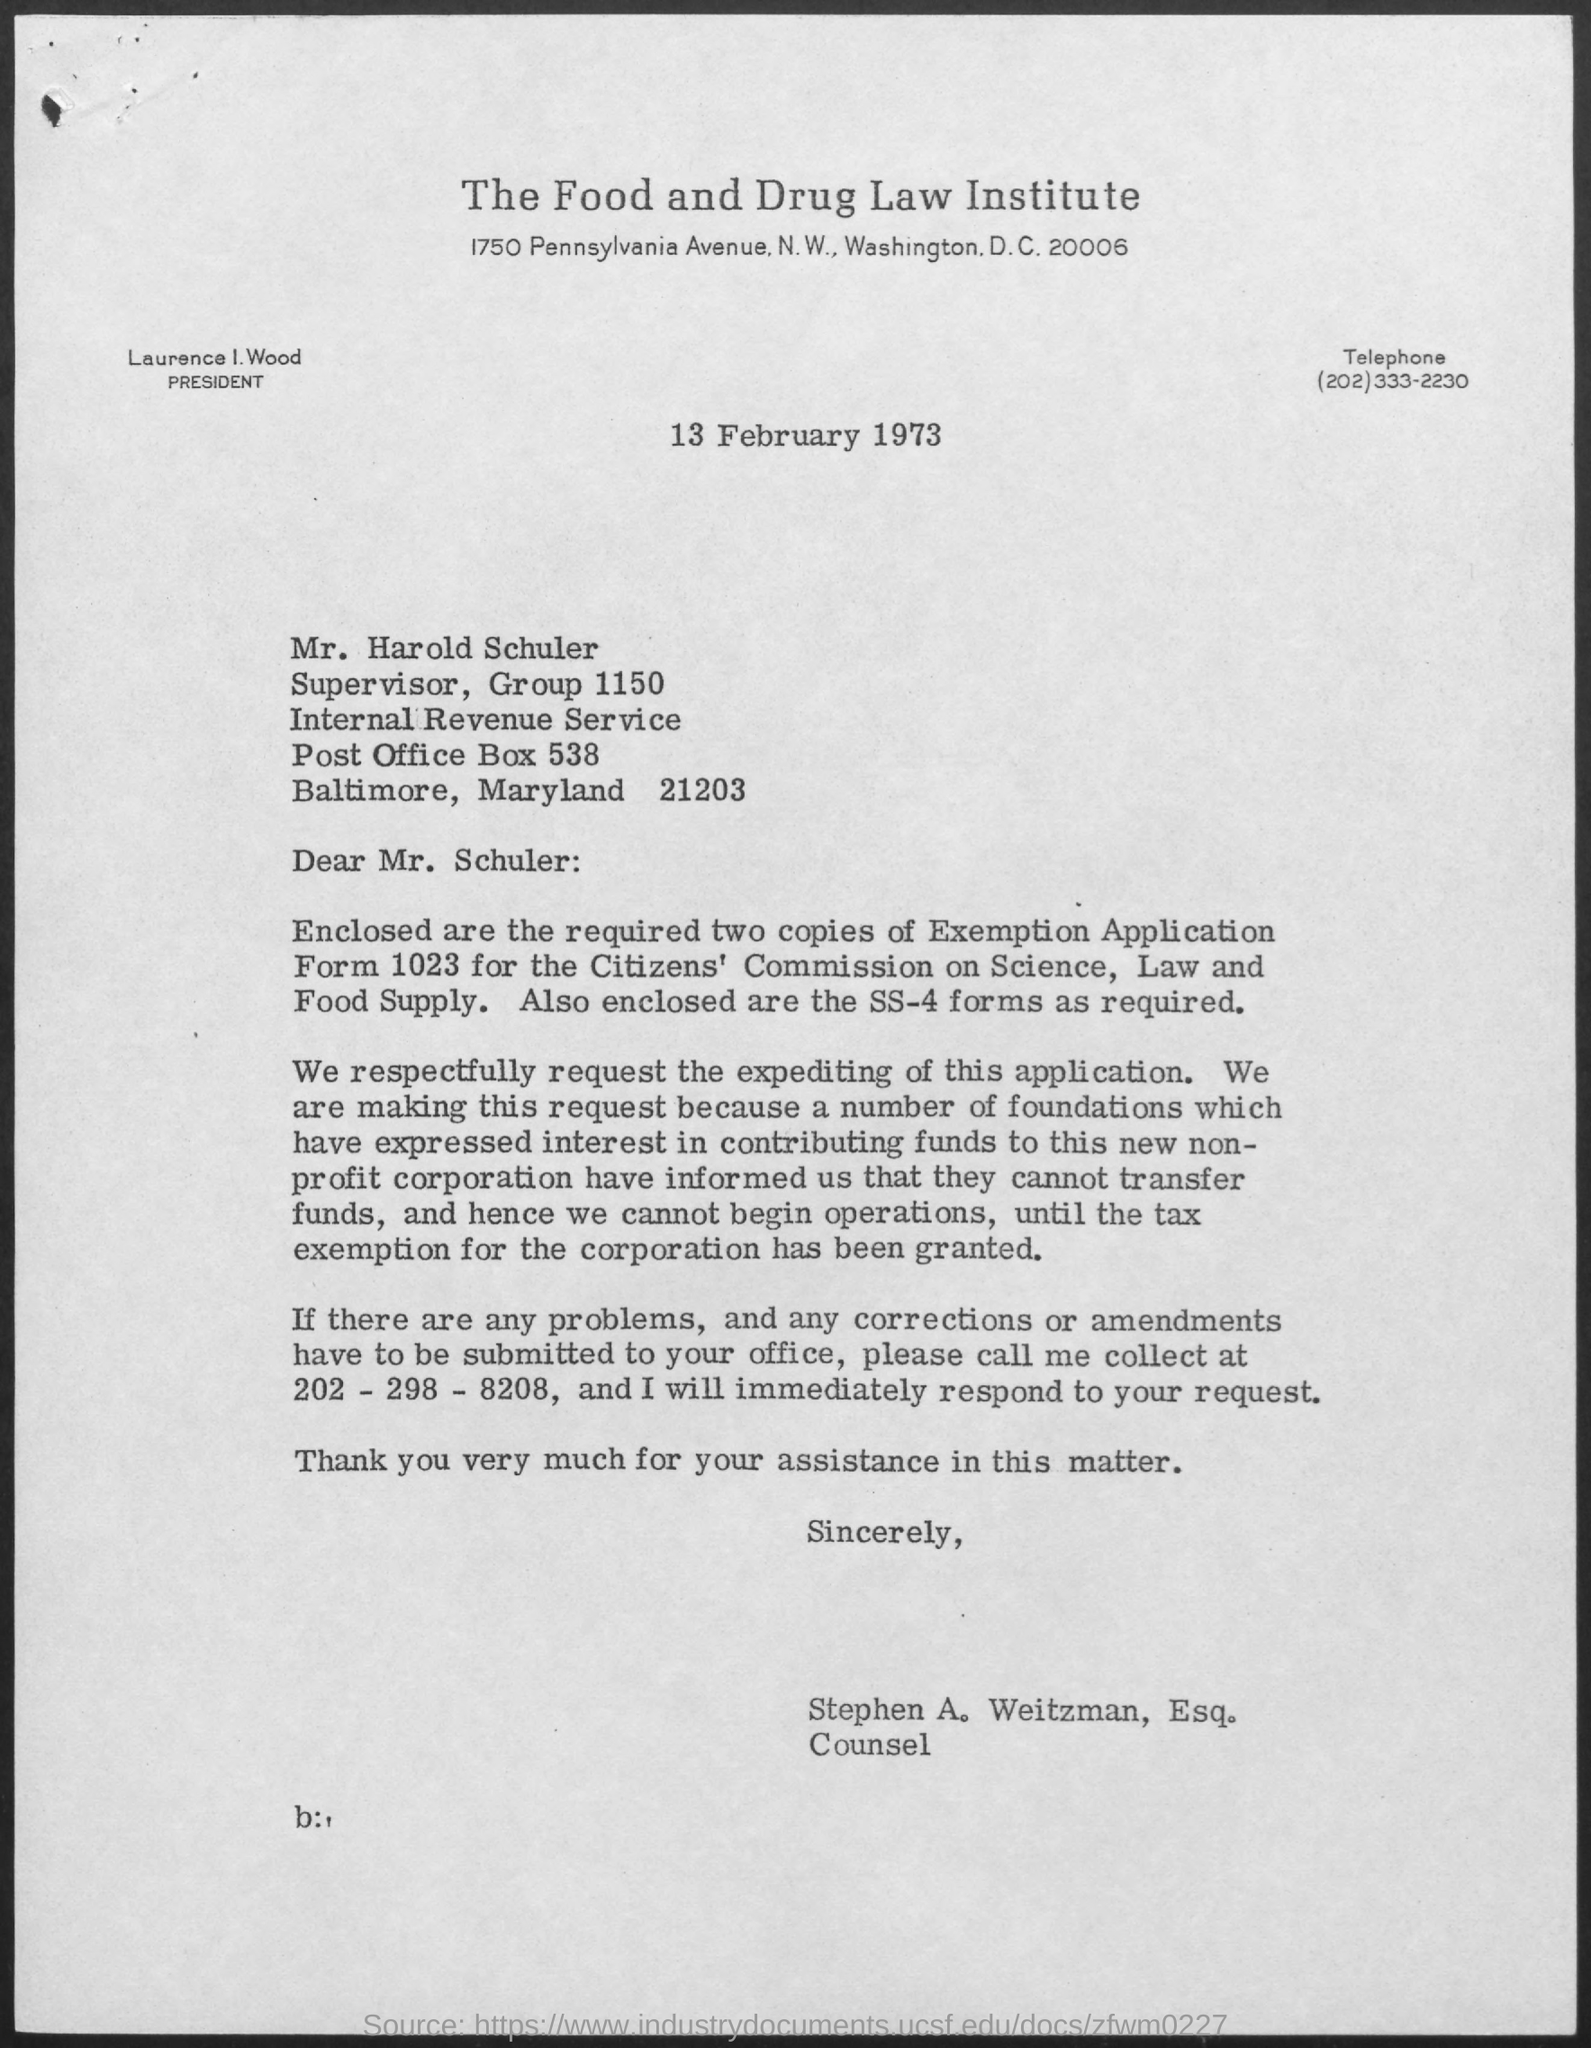What is the heading of the document?
Provide a short and direct response. The Food and Drug Law Institute. What is the date mentioned?
Your answer should be very brief. 13 February 1973. Who is the author of this document?
Offer a very short reply. Stephen A. Weitzman, Esq. Who is the president of the Institute?
Offer a terse response. Laurence I. Wood. 